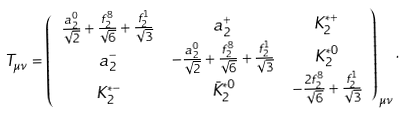Convert formula to latex. <formula><loc_0><loc_0><loc_500><loc_500>T _ { \mu \nu } & = \left ( \begin{array} { c c c } \frac { a _ { 2 } ^ { 0 } } { \sqrt { 2 } } + \frac { f _ { 2 } ^ { 8 } } { \sqrt { 6 } } + \frac { f _ { 2 } ^ { 1 } } { \sqrt { 3 } } & a _ { 2 } ^ { + } & K _ { 2 } ^ { * + } \\ a _ { 2 } ^ { - } & - \frac { a _ { 2 } ^ { 0 } } { \sqrt { 2 } } + \frac { f _ { 2 } ^ { 8 } } { \sqrt { 6 } } + \frac { f _ { 2 } ^ { 1 } } { \sqrt { 3 } } & K _ { 2 } ^ { * 0 } \\ K _ { 2 } ^ { * - } & \bar { K } _ { 2 } ^ { * 0 } & - \frac { 2 f _ { 2 } ^ { 8 } } { \sqrt { 6 } } + \frac { f _ { 2 } ^ { 1 } } { \sqrt { 3 } } \\ \end{array} \right ) _ { \mu \nu } \, .</formula> 